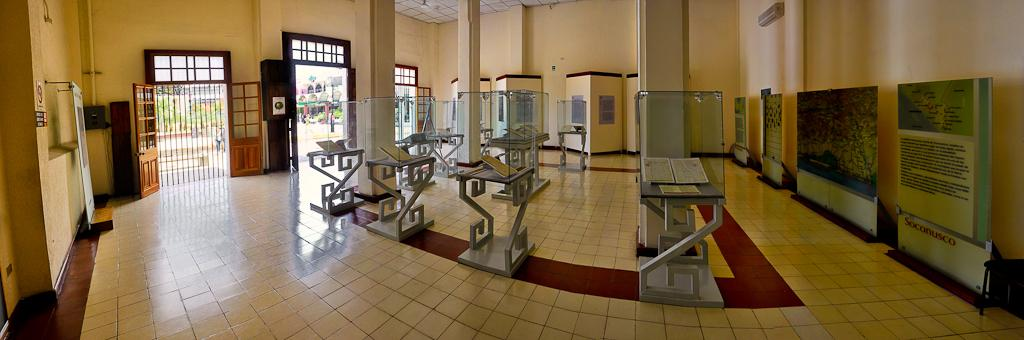What type of space is depicted in the image? The image shows the inside of a room. What can be seen on the walls of the room? There are boards visible in the room. What type of furniture is present in the room? There are tables present in the room. What type of rock is visible on the tables in the image? There is no rock visible on the tables in the image. 